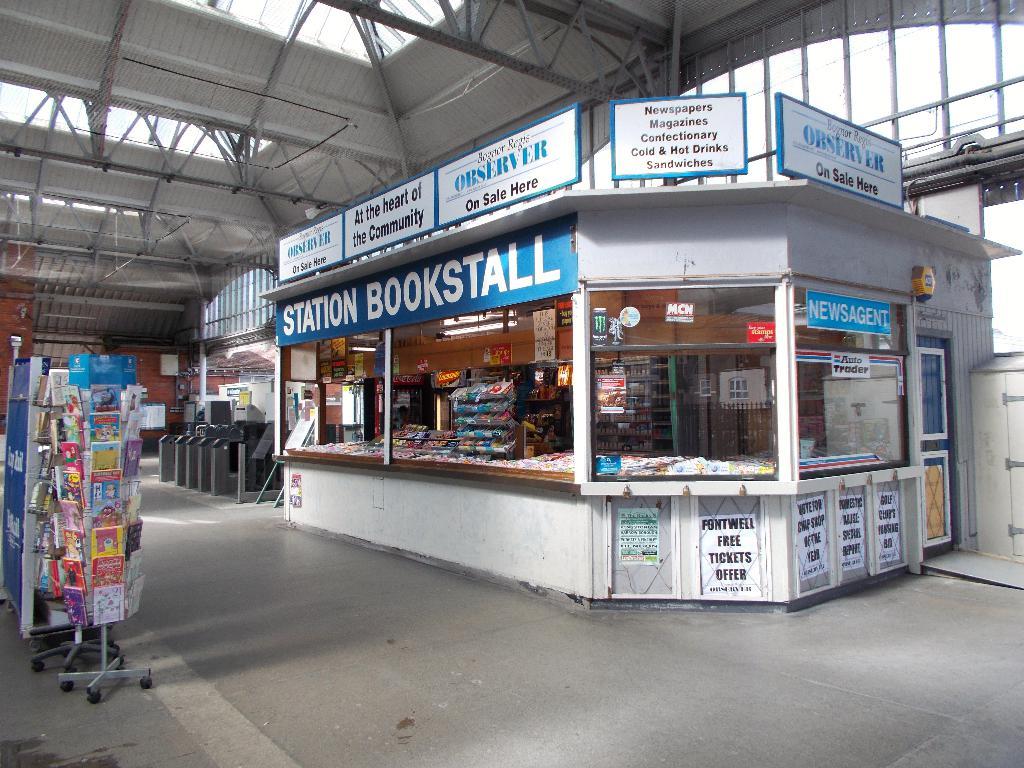What station is this?
Offer a very short reply. Bookstall. What type of beverages are sold in the large white building?
Keep it short and to the point. Cold and hot drinks. 